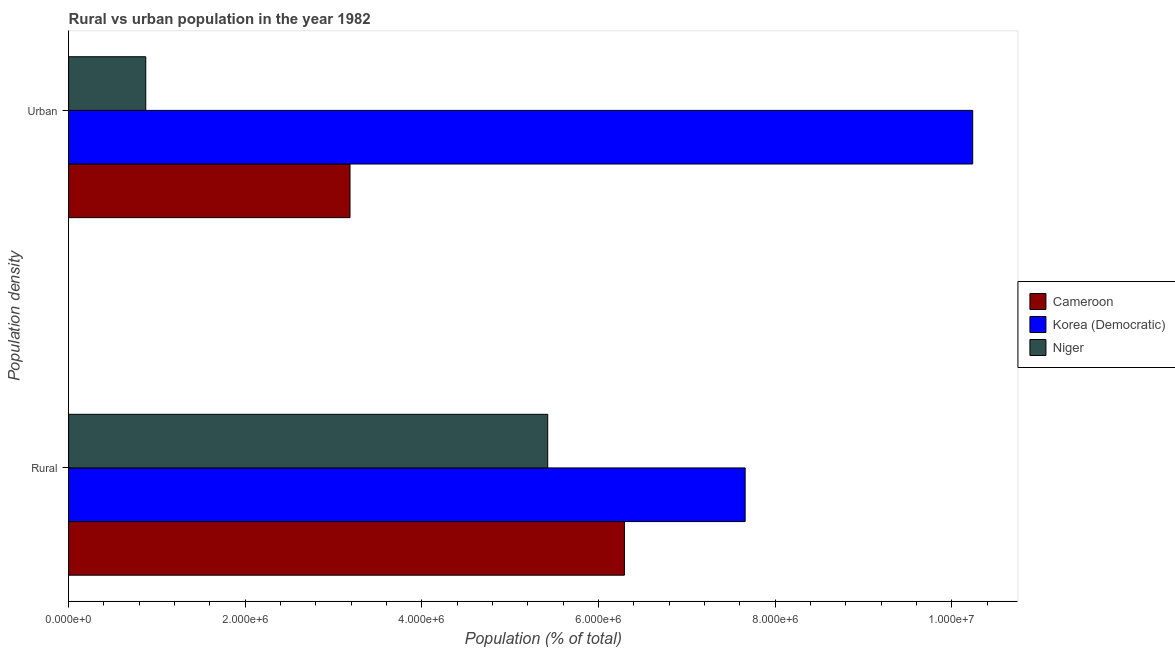Are the number of bars on each tick of the Y-axis equal?
Offer a very short reply. Yes. How many bars are there on the 1st tick from the bottom?
Provide a short and direct response. 3. What is the label of the 1st group of bars from the top?
Provide a succinct answer. Urban. What is the urban population density in Cameroon?
Ensure brevity in your answer.  3.19e+06. Across all countries, what is the maximum rural population density?
Keep it short and to the point. 7.66e+06. Across all countries, what is the minimum rural population density?
Offer a very short reply. 5.43e+06. In which country was the urban population density maximum?
Provide a short and direct response. Korea (Democratic). In which country was the rural population density minimum?
Keep it short and to the point. Niger. What is the total rural population density in the graph?
Keep it short and to the point. 1.94e+07. What is the difference between the urban population density in Cameroon and that in Niger?
Offer a very short reply. 2.31e+06. What is the difference between the urban population density in Cameroon and the rural population density in Niger?
Keep it short and to the point. -2.24e+06. What is the average urban population density per country?
Make the answer very short. 4.77e+06. What is the difference between the urban population density and rural population density in Niger?
Ensure brevity in your answer.  -4.55e+06. In how many countries, is the urban population density greater than 8400000 %?
Offer a terse response. 1. What is the ratio of the urban population density in Cameroon to that in Niger?
Your response must be concise. 3.65. What does the 3rd bar from the top in Rural represents?
Keep it short and to the point. Cameroon. What does the 2nd bar from the bottom in Rural represents?
Offer a very short reply. Korea (Democratic). How many bars are there?
Provide a short and direct response. 6. What is the difference between two consecutive major ticks on the X-axis?
Provide a short and direct response. 2.00e+06. Does the graph contain grids?
Your answer should be compact. No. Where does the legend appear in the graph?
Your answer should be very brief. Center right. How many legend labels are there?
Offer a very short reply. 3. How are the legend labels stacked?
Your answer should be compact. Vertical. What is the title of the graph?
Provide a succinct answer. Rural vs urban population in the year 1982. What is the label or title of the X-axis?
Ensure brevity in your answer.  Population (% of total). What is the label or title of the Y-axis?
Your answer should be compact. Population density. What is the Population (% of total) in Cameroon in Rural?
Make the answer very short. 6.29e+06. What is the Population (% of total) in Korea (Democratic) in Rural?
Offer a terse response. 7.66e+06. What is the Population (% of total) in Niger in Rural?
Make the answer very short. 5.43e+06. What is the Population (% of total) in Cameroon in Urban?
Keep it short and to the point. 3.19e+06. What is the Population (% of total) of Korea (Democratic) in Urban?
Keep it short and to the point. 1.02e+07. What is the Population (% of total) of Niger in Urban?
Your answer should be compact. 8.74e+05. Across all Population density, what is the maximum Population (% of total) of Cameroon?
Provide a short and direct response. 6.29e+06. Across all Population density, what is the maximum Population (% of total) in Korea (Democratic)?
Your answer should be compact. 1.02e+07. Across all Population density, what is the maximum Population (% of total) of Niger?
Your answer should be very brief. 5.43e+06. Across all Population density, what is the minimum Population (% of total) in Cameroon?
Your answer should be compact. 3.19e+06. Across all Population density, what is the minimum Population (% of total) in Korea (Democratic)?
Your answer should be compact. 7.66e+06. Across all Population density, what is the minimum Population (% of total) of Niger?
Offer a terse response. 8.74e+05. What is the total Population (% of total) in Cameroon in the graph?
Provide a short and direct response. 9.48e+06. What is the total Population (% of total) in Korea (Democratic) in the graph?
Offer a very short reply. 1.79e+07. What is the total Population (% of total) in Niger in the graph?
Keep it short and to the point. 6.30e+06. What is the difference between the Population (% of total) of Cameroon in Rural and that in Urban?
Provide a short and direct response. 3.11e+06. What is the difference between the Population (% of total) of Korea (Democratic) in Rural and that in Urban?
Offer a terse response. -2.58e+06. What is the difference between the Population (% of total) in Niger in Rural and that in Urban?
Make the answer very short. 4.55e+06. What is the difference between the Population (% of total) of Cameroon in Rural and the Population (% of total) of Korea (Democratic) in Urban?
Provide a succinct answer. -3.94e+06. What is the difference between the Population (% of total) in Cameroon in Rural and the Population (% of total) in Niger in Urban?
Offer a very short reply. 5.42e+06. What is the difference between the Population (% of total) in Korea (Democratic) in Rural and the Population (% of total) in Niger in Urban?
Your response must be concise. 6.79e+06. What is the average Population (% of total) of Cameroon per Population density?
Your answer should be compact. 4.74e+06. What is the average Population (% of total) of Korea (Democratic) per Population density?
Give a very brief answer. 8.95e+06. What is the average Population (% of total) in Niger per Population density?
Give a very brief answer. 3.15e+06. What is the difference between the Population (% of total) of Cameroon and Population (% of total) of Korea (Democratic) in Rural?
Give a very brief answer. -1.37e+06. What is the difference between the Population (% of total) in Cameroon and Population (% of total) in Niger in Rural?
Offer a terse response. 8.68e+05. What is the difference between the Population (% of total) in Korea (Democratic) and Population (% of total) in Niger in Rural?
Your response must be concise. 2.24e+06. What is the difference between the Population (% of total) of Cameroon and Population (% of total) of Korea (Democratic) in Urban?
Give a very brief answer. -7.05e+06. What is the difference between the Population (% of total) of Cameroon and Population (% of total) of Niger in Urban?
Provide a succinct answer. 2.31e+06. What is the difference between the Population (% of total) in Korea (Democratic) and Population (% of total) in Niger in Urban?
Make the answer very short. 9.36e+06. What is the ratio of the Population (% of total) of Cameroon in Rural to that in Urban?
Give a very brief answer. 1.98. What is the ratio of the Population (% of total) in Korea (Democratic) in Rural to that in Urban?
Offer a very short reply. 0.75. What is the ratio of the Population (% of total) of Niger in Rural to that in Urban?
Make the answer very short. 6.21. What is the difference between the highest and the second highest Population (% of total) in Cameroon?
Offer a very short reply. 3.11e+06. What is the difference between the highest and the second highest Population (% of total) of Korea (Democratic)?
Ensure brevity in your answer.  2.58e+06. What is the difference between the highest and the second highest Population (% of total) of Niger?
Make the answer very short. 4.55e+06. What is the difference between the highest and the lowest Population (% of total) of Cameroon?
Provide a short and direct response. 3.11e+06. What is the difference between the highest and the lowest Population (% of total) of Korea (Democratic)?
Your response must be concise. 2.58e+06. What is the difference between the highest and the lowest Population (% of total) in Niger?
Give a very brief answer. 4.55e+06. 